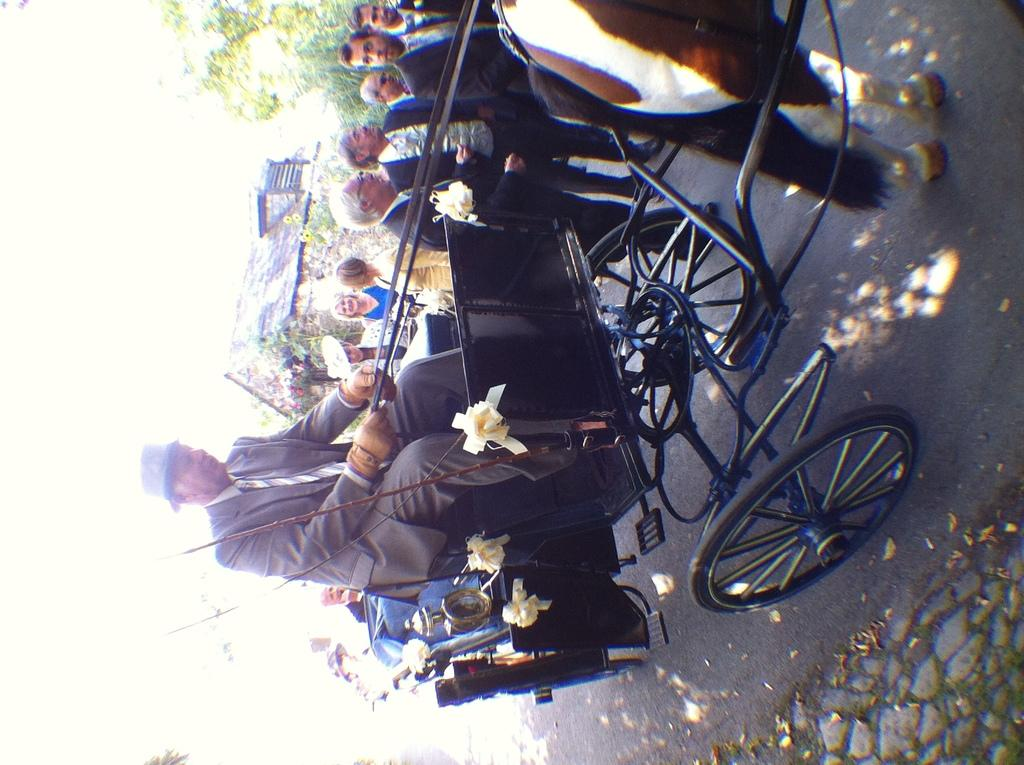How many people are in the image? There are people in the image, but the exact number is not specified. What are the people doing in the image? One person is riding a horse cart. What decorations are on the horse cart? There are flowers on the horse cart. What type of vegetation can be seen in the image? There are trees in the image. What type of building is in the image? There is a house in the image. What animal is pulling the horse cart? There is a horse in the image. What type of food is being prepared for the competition in the image? There is no mention of a competition or food preparation in the image. The image features people, a horse cart, flowers, trees, a house, and a horse. 